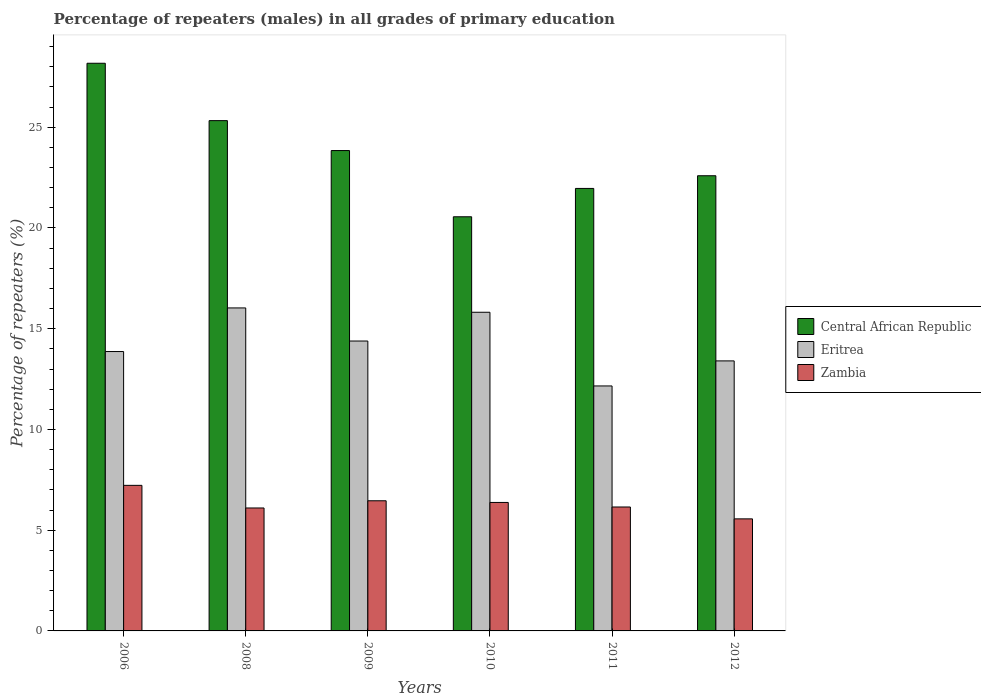How many different coloured bars are there?
Offer a terse response. 3. How many groups of bars are there?
Your answer should be very brief. 6. How many bars are there on the 3rd tick from the right?
Keep it short and to the point. 3. What is the label of the 1st group of bars from the left?
Keep it short and to the point. 2006. In how many cases, is the number of bars for a given year not equal to the number of legend labels?
Provide a succinct answer. 0. What is the percentage of repeaters (males) in Eritrea in 2010?
Offer a terse response. 15.82. Across all years, what is the maximum percentage of repeaters (males) in Zambia?
Your response must be concise. 7.22. Across all years, what is the minimum percentage of repeaters (males) in Central African Republic?
Provide a short and direct response. 20.56. In which year was the percentage of repeaters (males) in Eritrea maximum?
Your response must be concise. 2008. What is the total percentage of repeaters (males) in Eritrea in the graph?
Ensure brevity in your answer.  85.66. What is the difference between the percentage of repeaters (males) in Zambia in 2008 and that in 2010?
Offer a very short reply. -0.27. What is the difference between the percentage of repeaters (males) in Eritrea in 2008 and the percentage of repeaters (males) in Zambia in 2006?
Ensure brevity in your answer.  8.81. What is the average percentage of repeaters (males) in Central African Republic per year?
Your response must be concise. 23.74. In the year 2011, what is the difference between the percentage of repeaters (males) in Eritrea and percentage of repeaters (males) in Zambia?
Provide a short and direct response. 6.01. In how many years, is the percentage of repeaters (males) in Zambia greater than 22 %?
Your answer should be compact. 0. What is the ratio of the percentage of repeaters (males) in Central African Republic in 2011 to that in 2012?
Ensure brevity in your answer.  0.97. Is the difference between the percentage of repeaters (males) in Eritrea in 2006 and 2009 greater than the difference between the percentage of repeaters (males) in Zambia in 2006 and 2009?
Give a very brief answer. No. What is the difference between the highest and the second highest percentage of repeaters (males) in Zambia?
Offer a very short reply. 0.77. What is the difference between the highest and the lowest percentage of repeaters (males) in Central African Republic?
Provide a short and direct response. 7.62. In how many years, is the percentage of repeaters (males) in Zambia greater than the average percentage of repeaters (males) in Zambia taken over all years?
Make the answer very short. 3. What does the 2nd bar from the left in 2008 represents?
Keep it short and to the point. Eritrea. What does the 3rd bar from the right in 2010 represents?
Give a very brief answer. Central African Republic. Is it the case that in every year, the sum of the percentage of repeaters (males) in Zambia and percentage of repeaters (males) in Eritrea is greater than the percentage of repeaters (males) in Central African Republic?
Ensure brevity in your answer.  No. Are all the bars in the graph horizontal?
Make the answer very short. No. What is the difference between two consecutive major ticks on the Y-axis?
Make the answer very short. 5. Are the values on the major ticks of Y-axis written in scientific E-notation?
Your answer should be compact. No. Where does the legend appear in the graph?
Your answer should be compact. Center right. How are the legend labels stacked?
Make the answer very short. Vertical. What is the title of the graph?
Offer a very short reply. Percentage of repeaters (males) in all grades of primary education. Does "Sudan" appear as one of the legend labels in the graph?
Give a very brief answer. No. What is the label or title of the X-axis?
Your answer should be compact. Years. What is the label or title of the Y-axis?
Offer a very short reply. Percentage of repeaters (%). What is the Percentage of repeaters (%) of Central African Republic in 2006?
Your answer should be very brief. 28.17. What is the Percentage of repeaters (%) of Eritrea in 2006?
Your answer should be very brief. 13.87. What is the Percentage of repeaters (%) in Zambia in 2006?
Keep it short and to the point. 7.22. What is the Percentage of repeaters (%) of Central African Republic in 2008?
Make the answer very short. 25.33. What is the Percentage of repeaters (%) in Eritrea in 2008?
Your response must be concise. 16.03. What is the Percentage of repeaters (%) in Zambia in 2008?
Provide a short and direct response. 6.1. What is the Percentage of repeaters (%) in Central African Republic in 2009?
Provide a succinct answer. 23.84. What is the Percentage of repeaters (%) of Eritrea in 2009?
Your answer should be very brief. 14.39. What is the Percentage of repeaters (%) in Zambia in 2009?
Offer a terse response. 6.46. What is the Percentage of repeaters (%) of Central African Republic in 2010?
Offer a very short reply. 20.56. What is the Percentage of repeaters (%) of Eritrea in 2010?
Keep it short and to the point. 15.82. What is the Percentage of repeaters (%) of Zambia in 2010?
Give a very brief answer. 6.38. What is the Percentage of repeaters (%) in Central African Republic in 2011?
Ensure brevity in your answer.  21.96. What is the Percentage of repeaters (%) in Eritrea in 2011?
Your answer should be compact. 12.16. What is the Percentage of repeaters (%) of Zambia in 2011?
Your answer should be very brief. 6.15. What is the Percentage of repeaters (%) of Central African Republic in 2012?
Provide a succinct answer. 22.59. What is the Percentage of repeaters (%) in Eritrea in 2012?
Offer a very short reply. 13.4. What is the Percentage of repeaters (%) of Zambia in 2012?
Your answer should be compact. 5.56. Across all years, what is the maximum Percentage of repeaters (%) of Central African Republic?
Keep it short and to the point. 28.17. Across all years, what is the maximum Percentage of repeaters (%) of Eritrea?
Offer a terse response. 16.03. Across all years, what is the maximum Percentage of repeaters (%) in Zambia?
Your answer should be compact. 7.22. Across all years, what is the minimum Percentage of repeaters (%) of Central African Republic?
Provide a succinct answer. 20.56. Across all years, what is the minimum Percentage of repeaters (%) of Eritrea?
Ensure brevity in your answer.  12.16. Across all years, what is the minimum Percentage of repeaters (%) in Zambia?
Offer a very short reply. 5.56. What is the total Percentage of repeaters (%) in Central African Republic in the graph?
Provide a short and direct response. 142.45. What is the total Percentage of repeaters (%) of Eritrea in the graph?
Provide a short and direct response. 85.66. What is the total Percentage of repeaters (%) in Zambia in the graph?
Give a very brief answer. 37.88. What is the difference between the Percentage of repeaters (%) in Central African Republic in 2006 and that in 2008?
Ensure brevity in your answer.  2.85. What is the difference between the Percentage of repeaters (%) of Eritrea in 2006 and that in 2008?
Keep it short and to the point. -2.16. What is the difference between the Percentage of repeaters (%) of Zambia in 2006 and that in 2008?
Ensure brevity in your answer.  1.12. What is the difference between the Percentage of repeaters (%) in Central African Republic in 2006 and that in 2009?
Your answer should be compact. 4.33. What is the difference between the Percentage of repeaters (%) in Eritrea in 2006 and that in 2009?
Your answer should be very brief. -0.52. What is the difference between the Percentage of repeaters (%) in Zambia in 2006 and that in 2009?
Make the answer very short. 0.77. What is the difference between the Percentage of repeaters (%) in Central African Republic in 2006 and that in 2010?
Ensure brevity in your answer.  7.62. What is the difference between the Percentage of repeaters (%) of Eritrea in 2006 and that in 2010?
Offer a terse response. -1.95. What is the difference between the Percentage of repeaters (%) in Zambia in 2006 and that in 2010?
Your answer should be very brief. 0.85. What is the difference between the Percentage of repeaters (%) of Central African Republic in 2006 and that in 2011?
Your answer should be compact. 6.21. What is the difference between the Percentage of repeaters (%) in Eritrea in 2006 and that in 2011?
Offer a very short reply. 1.71. What is the difference between the Percentage of repeaters (%) in Zambia in 2006 and that in 2011?
Provide a short and direct response. 1.07. What is the difference between the Percentage of repeaters (%) in Central African Republic in 2006 and that in 2012?
Your answer should be very brief. 5.58. What is the difference between the Percentage of repeaters (%) of Eritrea in 2006 and that in 2012?
Give a very brief answer. 0.46. What is the difference between the Percentage of repeaters (%) of Zambia in 2006 and that in 2012?
Provide a succinct answer. 1.66. What is the difference between the Percentage of repeaters (%) of Central African Republic in 2008 and that in 2009?
Your answer should be very brief. 1.48. What is the difference between the Percentage of repeaters (%) in Eritrea in 2008 and that in 2009?
Give a very brief answer. 1.64. What is the difference between the Percentage of repeaters (%) of Zambia in 2008 and that in 2009?
Offer a terse response. -0.36. What is the difference between the Percentage of repeaters (%) in Central African Republic in 2008 and that in 2010?
Your answer should be compact. 4.77. What is the difference between the Percentage of repeaters (%) of Eritrea in 2008 and that in 2010?
Provide a succinct answer. 0.22. What is the difference between the Percentage of repeaters (%) of Zambia in 2008 and that in 2010?
Offer a very short reply. -0.27. What is the difference between the Percentage of repeaters (%) of Central African Republic in 2008 and that in 2011?
Your answer should be compact. 3.36. What is the difference between the Percentage of repeaters (%) in Eritrea in 2008 and that in 2011?
Offer a very short reply. 3.87. What is the difference between the Percentage of repeaters (%) of Zambia in 2008 and that in 2011?
Give a very brief answer. -0.05. What is the difference between the Percentage of repeaters (%) of Central African Republic in 2008 and that in 2012?
Your response must be concise. 2.73. What is the difference between the Percentage of repeaters (%) of Eritrea in 2008 and that in 2012?
Provide a short and direct response. 2.63. What is the difference between the Percentage of repeaters (%) of Zambia in 2008 and that in 2012?
Your answer should be very brief. 0.54. What is the difference between the Percentage of repeaters (%) of Central African Republic in 2009 and that in 2010?
Offer a very short reply. 3.29. What is the difference between the Percentage of repeaters (%) in Eritrea in 2009 and that in 2010?
Ensure brevity in your answer.  -1.43. What is the difference between the Percentage of repeaters (%) of Zambia in 2009 and that in 2010?
Your answer should be compact. 0.08. What is the difference between the Percentage of repeaters (%) in Central African Republic in 2009 and that in 2011?
Offer a terse response. 1.88. What is the difference between the Percentage of repeaters (%) in Eritrea in 2009 and that in 2011?
Give a very brief answer. 2.23. What is the difference between the Percentage of repeaters (%) of Zambia in 2009 and that in 2011?
Make the answer very short. 0.31. What is the difference between the Percentage of repeaters (%) in Central African Republic in 2009 and that in 2012?
Offer a very short reply. 1.25. What is the difference between the Percentage of repeaters (%) of Eritrea in 2009 and that in 2012?
Offer a terse response. 0.99. What is the difference between the Percentage of repeaters (%) of Zambia in 2009 and that in 2012?
Your response must be concise. 0.9. What is the difference between the Percentage of repeaters (%) of Central African Republic in 2010 and that in 2011?
Ensure brevity in your answer.  -1.41. What is the difference between the Percentage of repeaters (%) of Eritrea in 2010 and that in 2011?
Ensure brevity in your answer.  3.66. What is the difference between the Percentage of repeaters (%) of Zambia in 2010 and that in 2011?
Your response must be concise. 0.23. What is the difference between the Percentage of repeaters (%) in Central African Republic in 2010 and that in 2012?
Your response must be concise. -2.04. What is the difference between the Percentage of repeaters (%) in Eritrea in 2010 and that in 2012?
Make the answer very short. 2.41. What is the difference between the Percentage of repeaters (%) of Zambia in 2010 and that in 2012?
Your answer should be very brief. 0.81. What is the difference between the Percentage of repeaters (%) in Central African Republic in 2011 and that in 2012?
Keep it short and to the point. -0.63. What is the difference between the Percentage of repeaters (%) of Eritrea in 2011 and that in 2012?
Keep it short and to the point. -1.24. What is the difference between the Percentage of repeaters (%) in Zambia in 2011 and that in 2012?
Your answer should be compact. 0.59. What is the difference between the Percentage of repeaters (%) in Central African Republic in 2006 and the Percentage of repeaters (%) in Eritrea in 2008?
Make the answer very short. 12.14. What is the difference between the Percentage of repeaters (%) in Central African Republic in 2006 and the Percentage of repeaters (%) in Zambia in 2008?
Keep it short and to the point. 22.07. What is the difference between the Percentage of repeaters (%) of Eritrea in 2006 and the Percentage of repeaters (%) of Zambia in 2008?
Ensure brevity in your answer.  7.76. What is the difference between the Percentage of repeaters (%) in Central African Republic in 2006 and the Percentage of repeaters (%) in Eritrea in 2009?
Offer a terse response. 13.79. What is the difference between the Percentage of repeaters (%) in Central African Republic in 2006 and the Percentage of repeaters (%) in Zambia in 2009?
Give a very brief answer. 21.72. What is the difference between the Percentage of repeaters (%) in Eritrea in 2006 and the Percentage of repeaters (%) in Zambia in 2009?
Your answer should be very brief. 7.41. What is the difference between the Percentage of repeaters (%) in Central African Republic in 2006 and the Percentage of repeaters (%) in Eritrea in 2010?
Offer a terse response. 12.36. What is the difference between the Percentage of repeaters (%) of Central African Republic in 2006 and the Percentage of repeaters (%) of Zambia in 2010?
Offer a terse response. 21.8. What is the difference between the Percentage of repeaters (%) in Eritrea in 2006 and the Percentage of repeaters (%) in Zambia in 2010?
Your answer should be very brief. 7.49. What is the difference between the Percentage of repeaters (%) of Central African Republic in 2006 and the Percentage of repeaters (%) of Eritrea in 2011?
Provide a short and direct response. 16.02. What is the difference between the Percentage of repeaters (%) in Central African Republic in 2006 and the Percentage of repeaters (%) in Zambia in 2011?
Keep it short and to the point. 22.02. What is the difference between the Percentage of repeaters (%) of Eritrea in 2006 and the Percentage of repeaters (%) of Zambia in 2011?
Your response must be concise. 7.72. What is the difference between the Percentage of repeaters (%) in Central African Republic in 2006 and the Percentage of repeaters (%) in Eritrea in 2012?
Keep it short and to the point. 14.77. What is the difference between the Percentage of repeaters (%) of Central African Republic in 2006 and the Percentage of repeaters (%) of Zambia in 2012?
Your answer should be very brief. 22.61. What is the difference between the Percentage of repeaters (%) of Eritrea in 2006 and the Percentage of repeaters (%) of Zambia in 2012?
Your response must be concise. 8.31. What is the difference between the Percentage of repeaters (%) in Central African Republic in 2008 and the Percentage of repeaters (%) in Eritrea in 2009?
Provide a succinct answer. 10.94. What is the difference between the Percentage of repeaters (%) in Central African Republic in 2008 and the Percentage of repeaters (%) in Zambia in 2009?
Provide a short and direct response. 18.87. What is the difference between the Percentage of repeaters (%) in Eritrea in 2008 and the Percentage of repeaters (%) in Zambia in 2009?
Keep it short and to the point. 9.57. What is the difference between the Percentage of repeaters (%) of Central African Republic in 2008 and the Percentage of repeaters (%) of Eritrea in 2010?
Provide a succinct answer. 9.51. What is the difference between the Percentage of repeaters (%) of Central African Republic in 2008 and the Percentage of repeaters (%) of Zambia in 2010?
Provide a short and direct response. 18.95. What is the difference between the Percentage of repeaters (%) in Eritrea in 2008 and the Percentage of repeaters (%) in Zambia in 2010?
Ensure brevity in your answer.  9.65. What is the difference between the Percentage of repeaters (%) in Central African Republic in 2008 and the Percentage of repeaters (%) in Eritrea in 2011?
Your answer should be very brief. 13.17. What is the difference between the Percentage of repeaters (%) of Central African Republic in 2008 and the Percentage of repeaters (%) of Zambia in 2011?
Offer a very short reply. 19.18. What is the difference between the Percentage of repeaters (%) of Eritrea in 2008 and the Percentage of repeaters (%) of Zambia in 2011?
Offer a terse response. 9.88. What is the difference between the Percentage of repeaters (%) of Central African Republic in 2008 and the Percentage of repeaters (%) of Eritrea in 2012?
Give a very brief answer. 11.92. What is the difference between the Percentage of repeaters (%) of Central African Republic in 2008 and the Percentage of repeaters (%) of Zambia in 2012?
Ensure brevity in your answer.  19.77. What is the difference between the Percentage of repeaters (%) in Eritrea in 2008 and the Percentage of repeaters (%) in Zambia in 2012?
Your answer should be very brief. 10.47. What is the difference between the Percentage of repeaters (%) of Central African Republic in 2009 and the Percentage of repeaters (%) of Eritrea in 2010?
Your response must be concise. 8.03. What is the difference between the Percentage of repeaters (%) of Central African Republic in 2009 and the Percentage of repeaters (%) of Zambia in 2010?
Your answer should be compact. 17.47. What is the difference between the Percentage of repeaters (%) in Eritrea in 2009 and the Percentage of repeaters (%) in Zambia in 2010?
Give a very brief answer. 8.01. What is the difference between the Percentage of repeaters (%) of Central African Republic in 2009 and the Percentage of repeaters (%) of Eritrea in 2011?
Offer a terse response. 11.68. What is the difference between the Percentage of repeaters (%) in Central African Republic in 2009 and the Percentage of repeaters (%) in Zambia in 2011?
Offer a very short reply. 17.69. What is the difference between the Percentage of repeaters (%) in Eritrea in 2009 and the Percentage of repeaters (%) in Zambia in 2011?
Offer a very short reply. 8.24. What is the difference between the Percentage of repeaters (%) of Central African Republic in 2009 and the Percentage of repeaters (%) of Eritrea in 2012?
Give a very brief answer. 10.44. What is the difference between the Percentage of repeaters (%) of Central African Republic in 2009 and the Percentage of repeaters (%) of Zambia in 2012?
Your answer should be compact. 18.28. What is the difference between the Percentage of repeaters (%) in Eritrea in 2009 and the Percentage of repeaters (%) in Zambia in 2012?
Ensure brevity in your answer.  8.83. What is the difference between the Percentage of repeaters (%) in Central African Republic in 2010 and the Percentage of repeaters (%) in Eritrea in 2011?
Offer a very short reply. 8.4. What is the difference between the Percentage of repeaters (%) of Central African Republic in 2010 and the Percentage of repeaters (%) of Zambia in 2011?
Ensure brevity in your answer.  14.4. What is the difference between the Percentage of repeaters (%) in Eritrea in 2010 and the Percentage of repeaters (%) in Zambia in 2011?
Your response must be concise. 9.67. What is the difference between the Percentage of repeaters (%) in Central African Republic in 2010 and the Percentage of repeaters (%) in Eritrea in 2012?
Make the answer very short. 7.15. What is the difference between the Percentage of repeaters (%) in Central African Republic in 2010 and the Percentage of repeaters (%) in Zambia in 2012?
Provide a succinct answer. 14.99. What is the difference between the Percentage of repeaters (%) in Eritrea in 2010 and the Percentage of repeaters (%) in Zambia in 2012?
Make the answer very short. 10.25. What is the difference between the Percentage of repeaters (%) of Central African Republic in 2011 and the Percentage of repeaters (%) of Eritrea in 2012?
Your answer should be compact. 8.56. What is the difference between the Percentage of repeaters (%) in Central African Republic in 2011 and the Percentage of repeaters (%) in Zambia in 2012?
Offer a terse response. 16.4. What is the difference between the Percentage of repeaters (%) of Eritrea in 2011 and the Percentage of repeaters (%) of Zambia in 2012?
Give a very brief answer. 6.6. What is the average Percentage of repeaters (%) of Central African Republic per year?
Your answer should be very brief. 23.74. What is the average Percentage of repeaters (%) of Eritrea per year?
Provide a short and direct response. 14.28. What is the average Percentage of repeaters (%) in Zambia per year?
Your answer should be compact. 6.31. In the year 2006, what is the difference between the Percentage of repeaters (%) in Central African Republic and Percentage of repeaters (%) in Eritrea?
Offer a very short reply. 14.31. In the year 2006, what is the difference between the Percentage of repeaters (%) of Central African Republic and Percentage of repeaters (%) of Zambia?
Make the answer very short. 20.95. In the year 2006, what is the difference between the Percentage of repeaters (%) in Eritrea and Percentage of repeaters (%) in Zambia?
Your response must be concise. 6.64. In the year 2008, what is the difference between the Percentage of repeaters (%) of Central African Republic and Percentage of repeaters (%) of Eritrea?
Your response must be concise. 9.3. In the year 2008, what is the difference between the Percentage of repeaters (%) in Central African Republic and Percentage of repeaters (%) in Zambia?
Make the answer very short. 19.22. In the year 2008, what is the difference between the Percentage of repeaters (%) in Eritrea and Percentage of repeaters (%) in Zambia?
Ensure brevity in your answer.  9.93. In the year 2009, what is the difference between the Percentage of repeaters (%) of Central African Republic and Percentage of repeaters (%) of Eritrea?
Provide a short and direct response. 9.45. In the year 2009, what is the difference between the Percentage of repeaters (%) of Central African Republic and Percentage of repeaters (%) of Zambia?
Provide a succinct answer. 17.38. In the year 2009, what is the difference between the Percentage of repeaters (%) in Eritrea and Percentage of repeaters (%) in Zambia?
Offer a very short reply. 7.93. In the year 2010, what is the difference between the Percentage of repeaters (%) of Central African Republic and Percentage of repeaters (%) of Eritrea?
Make the answer very short. 4.74. In the year 2010, what is the difference between the Percentage of repeaters (%) in Central African Republic and Percentage of repeaters (%) in Zambia?
Offer a very short reply. 14.18. In the year 2010, what is the difference between the Percentage of repeaters (%) of Eritrea and Percentage of repeaters (%) of Zambia?
Provide a short and direct response. 9.44. In the year 2011, what is the difference between the Percentage of repeaters (%) of Central African Republic and Percentage of repeaters (%) of Eritrea?
Offer a terse response. 9.8. In the year 2011, what is the difference between the Percentage of repeaters (%) in Central African Republic and Percentage of repeaters (%) in Zambia?
Your response must be concise. 15.81. In the year 2011, what is the difference between the Percentage of repeaters (%) in Eritrea and Percentage of repeaters (%) in Zambia?
Your response must be concise. 6.01. In the year 2012, what is the difference between the Percentage of repeaters (%) of Central African Republic and Percentage of repeaters (%) of Eritrea?
Keep it short and to the point. 9.19. In the year 2012, what is the difference between the Percentage of repeaters (%) in Central African Republic and Percentage of repeaters (%) in Zambia?
Offer a terse response. 17.03. In the year 2012, what is the difference between the Percentage of repeaters (%) in Eritrea and Percentage of repeaters (%) in Zambia?
Make the answer very short. 7.84. What is the ratio of the Percentage of repeaters (%) in Central African Republic in 2006 to that in 2008?
Make the answer very short. 1.11. What is the ratio of the Percentage of repeaters (%) in Eritrea in 2006 to that in 2008?
Provide a succinct answer. 0.86. What is the ratio of the Percentage of repeaters (%) of Zambia in 2006 to that in 2008?
Make the answer very short. 1.18. What is the ratio of the Percentage of repeaters (%) in Central African Republic in 2006 to that in 2009?
Offer a very short reply. 1.18. What is the ratio of the Percentage of repeaters (%) in Eritrea in 2006 to that in 2009?
Your answer should be very brief. 0.96. What is the ratio of the Percentage of repeaters (%) of Zambia in 2006 to that in 2009?
Ensure brevity in your answer.  1.12. What is the ratio of the Percentage of repeaters (%) of Central African Republic in 2006 to that in 2010?
Ensure brevity in your answer.  1.37. What is the ratio of the Percentage of repeaters (%) in Eritrea in 2006 to that in 2010?
Give a very brief answer. 0.88. What is the ratio of the Percentage of repeaters (%) of Zambia in 2006 to that in 2010?
Ensure brevity in your answer.  1.13. What is the ratio of the Percentage of repeaters (%) in Central African Republic in 2006 to that in 2011?
Your response must be concise. 1.28. What is the ratio of the Percentage of repeaters (%) of Eritrea in 2006 to that in 2011?
Your answer should be compact. 1.14. What is the ratio of the Percentage of repeaters (%) in Zambia in 2006 to that in 2011?
Your answer should be compact. 1.17. What is the ratio of the Percentage of repeaters (%) in Central African Republic in 2006 to that in 2012?
Provide a short and direct response. 1.25. What is the ratio of the Percentage of repeaters (%) in Eritrea in 2006 to that in 2012?
Provide a short and direct response. 1.03. What is the ratio of the Percentage of repeaters (%) of Zambia in 2006 to that in 2012?
Ensure brevity in your answer.  1.3. What is the ratio of the Percentage of repeaters (%) of Central African Republic in 2008 to that in 2009?
Make the answer very short. 1.06. What is the ratio of the Percentage of repeaters (%) in Eritrea in 2008 to that in 2009?
Give a very brief answer. 1.11. What is the ratio of the Percentage of repeaters (%) of Zambia in 2008 to that in 2009?
Make the answer very short. 0.94. What is the ratio of the Percentage of repeaters (%) in Central African Republic in 2008 to that in 2010?
Your answer should be very brief. 1.23. What is the ratio of the Percentage of repeaters (%) of Eritrea in 2008 to that in 2010?
Offer a terse response. 1.01. What is the ratio of the Percentage of repeaters (%) of Central African Republic in 2008 to that in 2011?
Make the answer very short. 1.15. What is the ratio of the Percentage of repeaters (%) of Eritrea in 2008 to that in 2011?
Your response must be concise. 1.32. What is the ratio of the Percentage of repeaters (%) of Zambia in 2008 to that in 2011?
Your answer should be very brief. 0.99. What is the ratio of the Percentage of repeaters (%) in Central African Republic in 2008 to that in 2012?
Offer a terse response. 1.12. What is the ratio of the Percentage of repeaters (%) of Eritrea in 2008 to that in 2012?
Provide a short and direct response. 1.2. What is the ratio of the Percentage of repeaters (%) of Zambia in 2008 to that in 2012?
Your answer should be compact. 1.1. What is the ratio of the Percentage of repeaters (%) in Central African Republic in 2009 to that in 2010?
Offer a very short reply. 1.16. What is the ratio of the Percentage of repeaters (%) of Eritrea in 2009 to that in 2010?
Your answer should be very brief. 0.91. What is the ratio of the Percentage of repeaters (%) of Central African Republic in 2009 to that in 2011?
Ensure brevity in your answer.  1.09. What is the ratio of the Percentage of repeaters (%) in Eritrea in 2009 to that in 2011?
Your answer should be compact. 1.18. What is the ratio of the Percentage of repeaters (%) in Zambia in 2009 to that in 2011?
Your response must be concise. 1.05. What is the ratio of the Percentage of repeaters (%) in Central African Republic in 2009 to that in 2012?
Keep it short and to the point. 1.06. What is the ratio of the Percentage of repeaters (%) in Eritrea in 2009 to that in 2012?
Ensure brevity in your answer.  1.07. What is the ratio of the Percentage of repeaters (%) in Zambia in 2009 to that in 2012?
Your response must be concise. 1.16. What is the ratio of the Percentage of repeaters (%) in Central African Republic in 2010 to that in 2011?
Provide a short and direct response. 0.94. What is the ratio of the Percentage of repeaters (%) in Eritrea in 2010 to that in 2011?
Your answer should be very brief. 1.3. What is the ratio of the Percentage of repeaters (%) of Zambia in 2010 to that in 2011?
Your answer should be compact. 1.04. What is the ratio of the Percentage of repeaters (%) in Central African Republic in 2010 to that in 2012?
Your answer should be compact. 0.91. What is the ratio of the Percentage of repeaters (%) of Eritrea in 2010 to that in 2012?
Make the answer very short. 1.18. What is the ratio of the Percentage of repeaters (%) in Zambia in 2010 to that in 2012?
Give a very brief answer. 1.15. What is the ratio of the Percentage of repeaters (%) of Central African Republic in 2011 to that in 2012?
Your answer should be very brief. 0.97. What is the ratio of the Percentage of repeaters (%) of Eritrea in 2011 to that in 2012?
Provide a succinct answer. 0.91. What is the ratio of the Percentage of repeaters (%) in Zambia in 2011 to that in 2012?
Provide a short and direct response. 1.11. What is the difference between the highest and the second highest Percentage of repeaters (%) of Central African Republic?
Ensure brevity in your answer.  2.85. What is the difference between the highest and the second highest Percentage of repeaters (%) of Eritrea?
Your response must be concise. 0.22. What is the difference between the highest and the second highest Percentage of repeaters (%) of Zambia?
Provide a succinct answer. 0.77. What is the difference between the highest and the lowest Percentage of repeaters (%) in Central African Republic?
Ensure brevity in your answer.  7.62. What is the difference between the highest and the lowest Percentage of repeaters (%) of Eritrea?
Your answer should be compact. 3.87. What is the difference between the highest and the lowest Percentage of repeaters (%) of Zambia?
Offer a terse response. 1.66. 